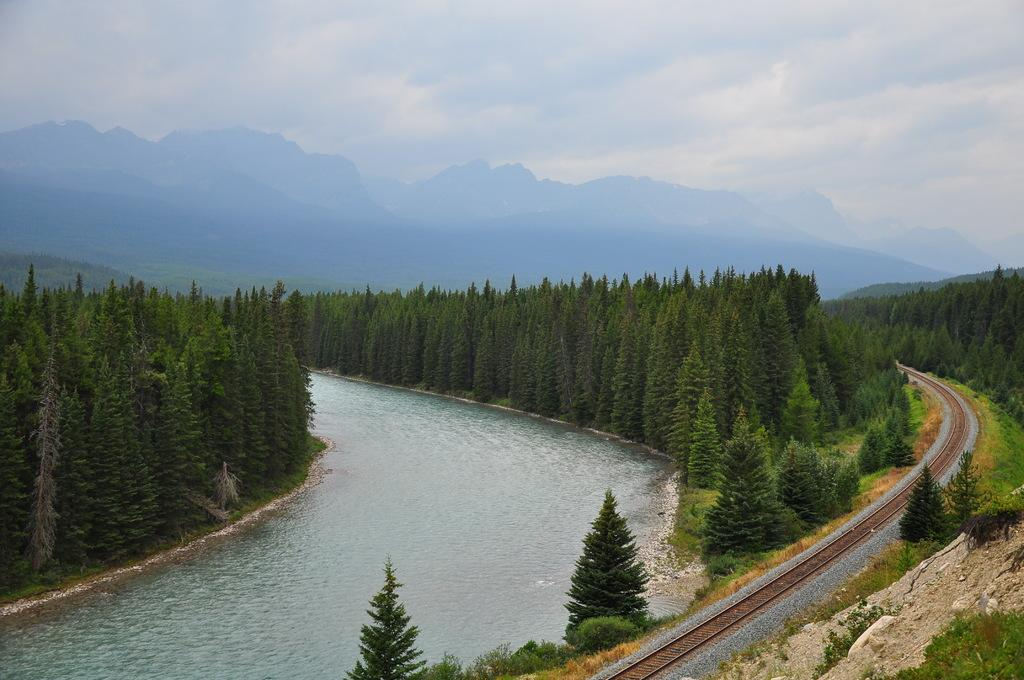What is the main element present in the image? There is water in the image. What other natural elements can be seen in the image? There are trees in the image. How are the trees arranged in the image? The trees are positioned from left to right. What man-made structure is visible in the image? There is a railway track on the right side of the image. What is the weather condition in the image? The sky is cloudy in the image. What type of thought is being expressed by the cabbage in the image? There is no cabbage present in the image, and therefore no thoughts can be attributed to it. 